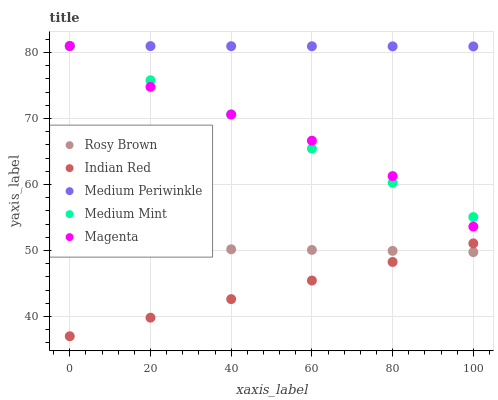Does Indian Red have the minimum area under the curve?
Answer yes or no. Yes. Does Medium Periwinkle have the maximum area under the curve?
Answer yes or no. Yes. Does Magenta have the minimum area under the curve?
Answer yes or no. No. Does Magenta have the maximum area under the curve?
Answer yes or no. No. Is Medium Periwinkle the smoothest?
Answer yes or no. Yes. Is Magenta the roughest?
Answer yes or no. Yes. Is Rosy Brown the smoothest?
Answer yes or no. No. Is Rosy Brown the roughest?
Answer yes or no. No. Does Indian Red have the lowest value?
Answer yes or no. Yes. Does Magenta have the lowest value?
Answer yes or no. No. Does Medium Periwinkle have the highest value?
Answer yes or no. Yes. Does Rosy Brown have the highest value?
Answer yes or no. No. Is Rosy Brown less than Medium Periwinkle?
Answer yes or no. Yes. Is Magenta greater than Rosy Brown?
Answer yes or no. Yes. Does Medium Mint intersect Magenta?
Answer yes or no. Yes. Is Medium Mint less than Magenta?
Answer yes or no. No. Is Medium Mint greater than Magenta?
Answer yes or no. No. Does Rosy Brown intersect Medium Periwinkle?
Answer yes or no. No. 